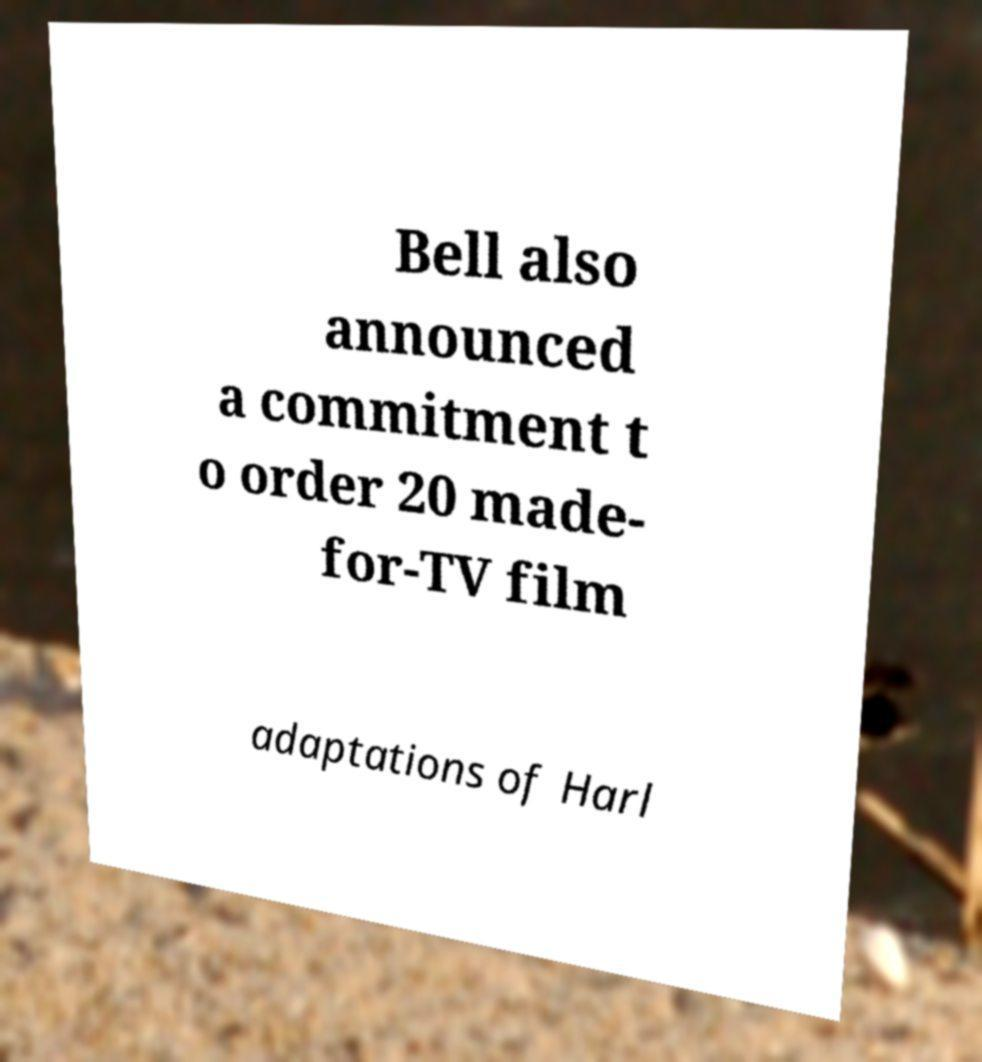Could you assist in decoding the text presented in this image and type it out clearly? Bell also announced a commitment t o order 20 made- for-TV film adaptations of Harl 